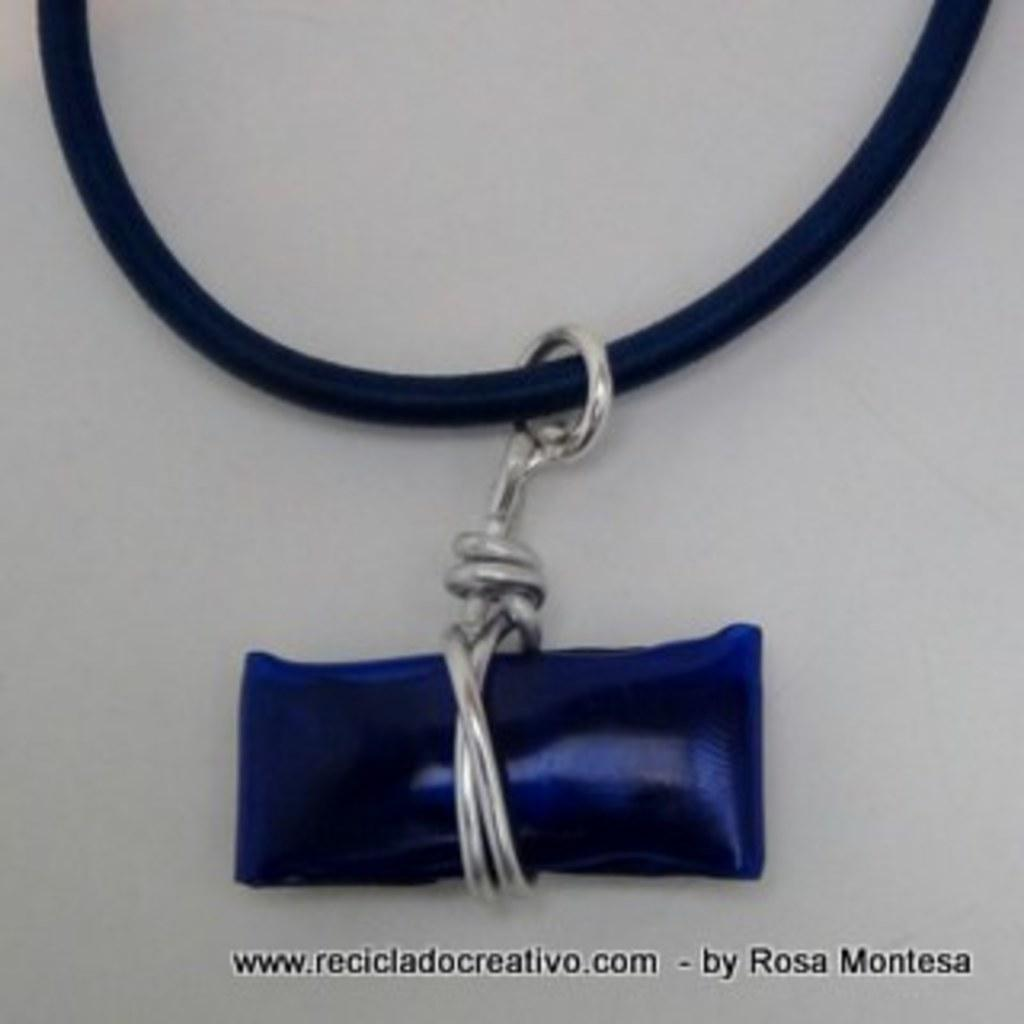What is the main object in the image? There is a locket in the image. How is the locket attached to the chain? The locket is on a chain. What is the color of the surface on which the locket and chain are placed? The locket and chain are placed on a white surface. What type of jeans is the person wearing in the image? There is no person or jeans present in the image; it only features a locket on a chain placed on a white surface. What surprise can be seen in the image? There is no surprise or unexpected element in the image; it is a simple image of a locket on a chain placed on a white surface. 